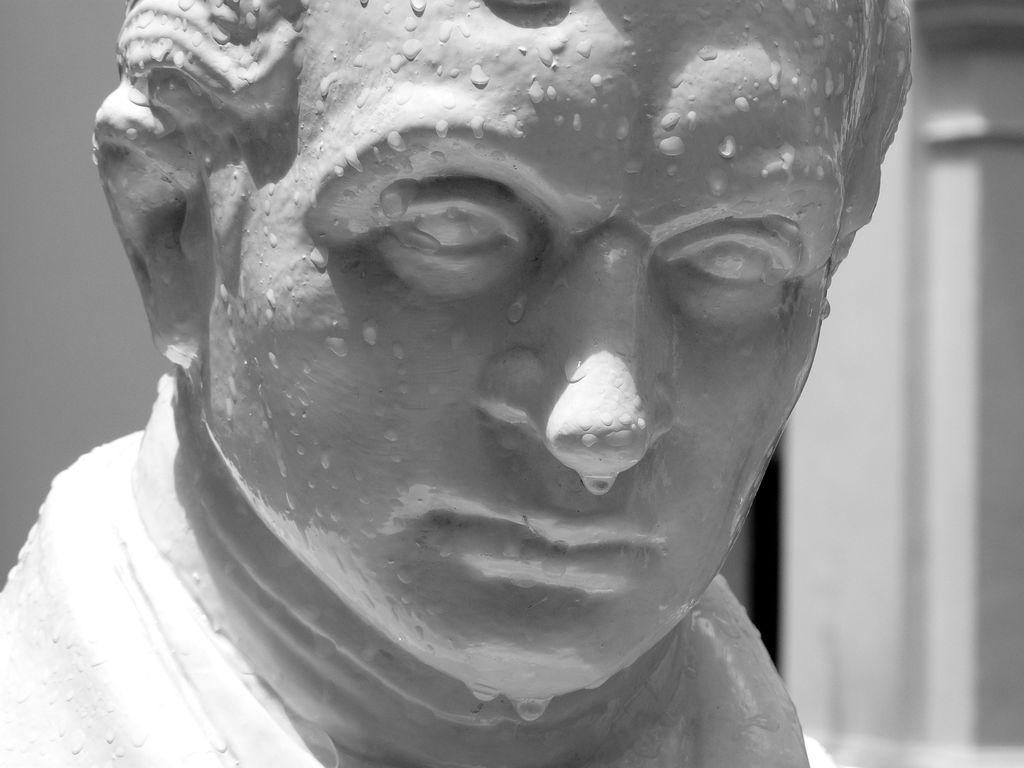What is the main subject of the image? There is a statue of a man in the image. What else can be seen in the image besides the statue? Water drops are visible in the image. What is visible in the background of the image? There is a wall in the background of the image. What type of screw is holding the statue together in the image? There is no screw present in the image; it is a statue of a man. What time of day is depicted in the image? The time of day is not mentioned or depicted in the image. 